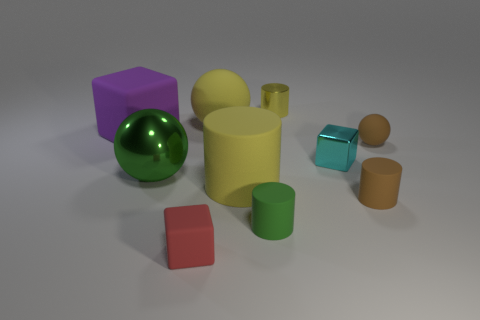Do the tiny green rubber thing and the yellow shiny object have the same shape?
Make the answer very short. Yes. What number of objects are either tiny things in front of the green matte object or tiny cyan metallic objects?
Your answer should be compact. 2. What size is the purple object that is the same material as the green cylinder?
Keep it short and to the point. Large. How many tiny objects have the same color as the large rubber cylinder?
Make the answer very short. 1. What number of tiny objects are either yellow matte balls or yellow cylinders?
Offer a terse response. 1. What is the size of the matte cylinder that is the same color as the big metallic sphere?
Your response must be concise. Small. Are there any other tiny things made of the same material as the purple object?
Provide a short and direct response. Yes. There is a small thing left of the big yellow rubber ball; what is it made of?
Provide a short and direct response. Rubber. There is a large sphere right of the small red rubber block; is its color the same as the cylinder that is on the left side of the green rubber object?
Offer a very short reply. Yes. What is the color of the cylinder that is the same size as the purple matte object?
Give a very brief answer. Yellow. 